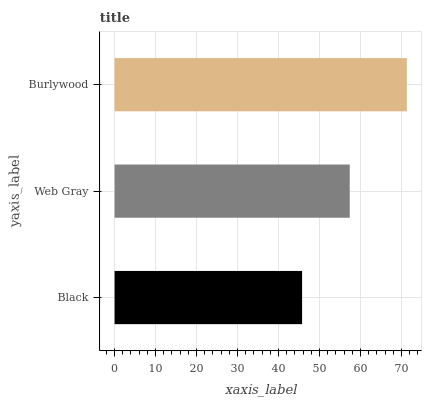Is Black the minimum?
Answer yes or no. Yes. Is Burlywood the maximum?
Answer yes or no. Yes. Is Web Gray the minimum?
Answer yes or no. No. Is Web Gray the maximum?
Answer yes or no. No. Is Web Gray greater than Black?
Answer yes or no. Yes. Is Black less than Web Gray?
Answer yes or no. Yes. Is Black greater than Web Gray?
Answer yes or no. No. Is Web Gray less than Black?
Answer yes or no. No. Is Web Gray the high median?
Answer yes or no. Yes. Is Web Gray the low median?
Answer yes or no. Yes. Is Black the high median?
Answer yes or no. No. Is Black the low median?
Answer yes or no. No. 